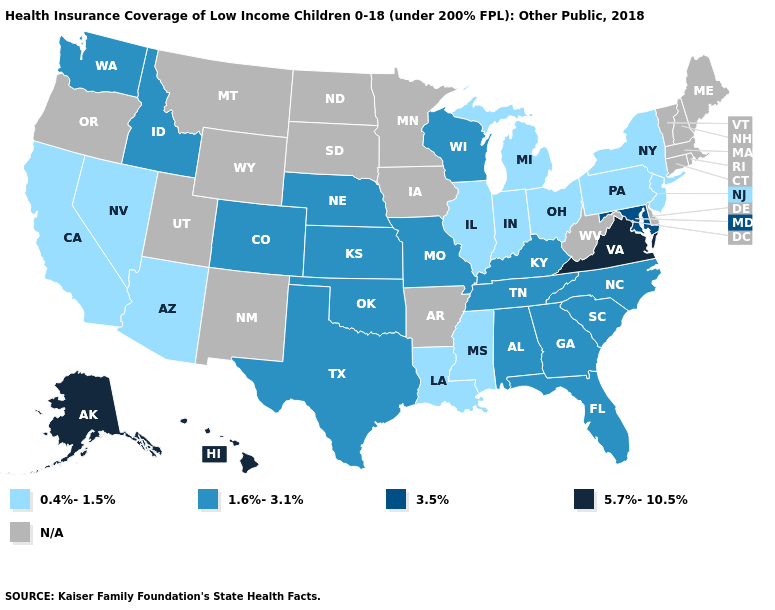What is the lowest value in the USA?
Give a very brief answer. 0.4%-1.5%. What is the highest value in the USA?
Answer briefly. 5.7%-10.5%. What is the value of South Carolina?
Keep it brief. 1.6%-3.1%. How many symbols are there in the legend?
Concise answer only. 5. What is the lowest value in states that border North Carolina?
Short answer required. 1.6%-3.1%. What is the value of Pennsylvania?
Short answer required. 0.4%-1.5%. Which states have the highest value in the USA?
Short answer required. Alaska, Hawaii, Virginia. Name the states that have a value in the range 3.5%?
Give a very brief answer. Maryland. How many symbols are there in the legend?
Keep it brief. 5. Does Nebraska have the highest value in the MidWest?
Be succinct. Yes. Among the states that border Wisconsin , which have the highest value?
Be succinct. Illinois, Michigan. Name the states that have a value in the range 3.5%?
Short answer required. Maryland. What is the lowest value in the South?
Write a very short answer. 0.4%-1.5%. What is the value of Pennsylvania?
Short answer required. 0.4%-1.5%. 